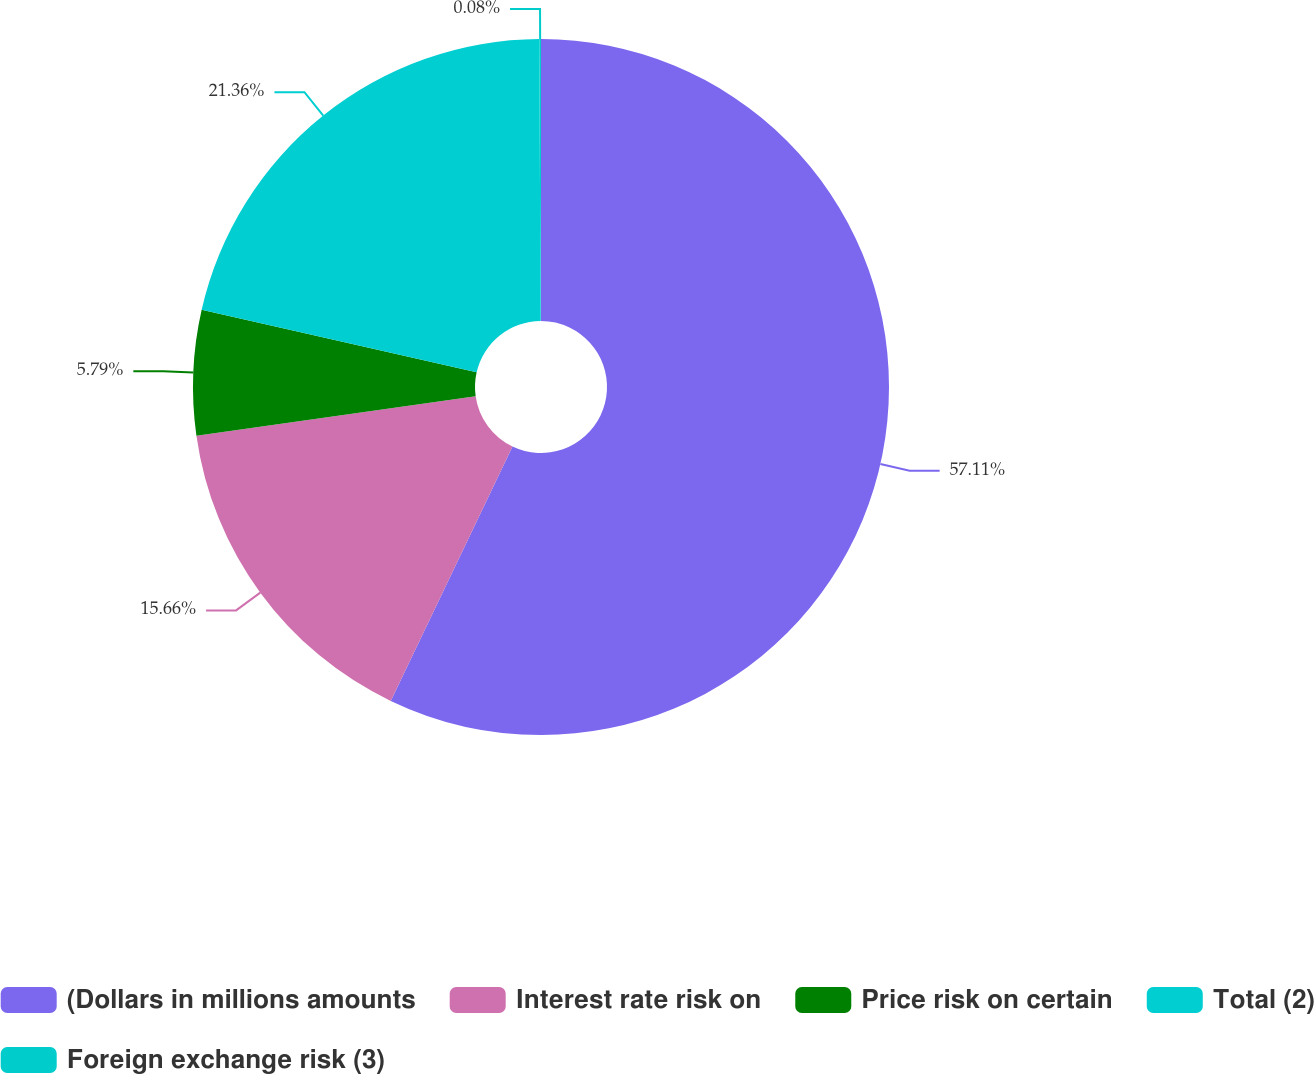Convert chart. <chart><loc_0><loc_0><loc_500><loc_500><pie_chart><fcel>(Dollars in millions amounts<fcel>Interest rate risk on<fcel>Price risk on certain<fcel>Total (2)<fcel>Foreign exchange risk (3)<nl><fcel>57.1%<fcel>15.66%<fcel>5.79%<fcel>21.36%<fcel>0.08%<nl></chart> 